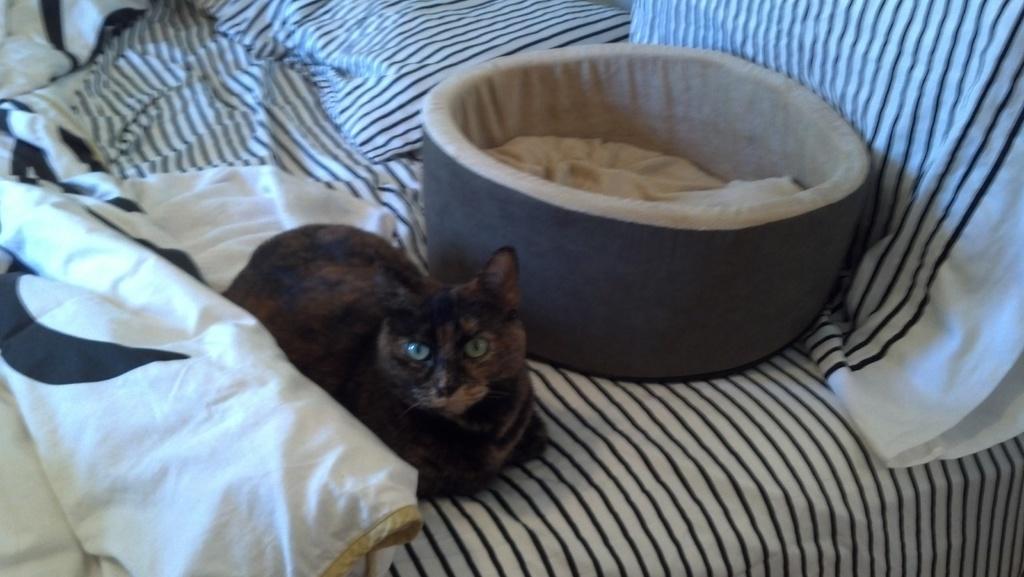How would you summarize this image in a sentence or two? In the picture we can see a bed with some cloth on it and on it we can see some bowl with food and near it, we can see a cat sitting which is black in color. 